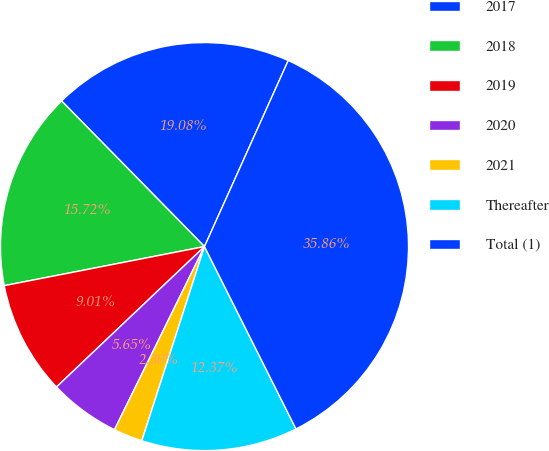<chart> <loc_0><loc_0><loc_500><loc_500><pie_chart><fcel>2017<fcel>2018<fcel>2019<fcel>2020<fcel>2021<fcel>Thereafter<fcel>Total (1)<nl><fcel>19.08%<fcel>15.72%<fcel>9.01%<fcel>5.65%<fcel>2.3%<fcel>12.37%<fcel>35.86%<nl></chart> 